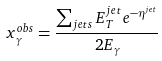Convert formula to latex. <formula><loc_0><loc_0><loc_500><loc_500>x _ { \gamma } ^ { o b s } = \frac { \sum _ { j e t s } E _ { T } ^ { j e t } e ^ { - \eta ^ { j e t } } } { 2 E _ { \gamma } }</formula> 